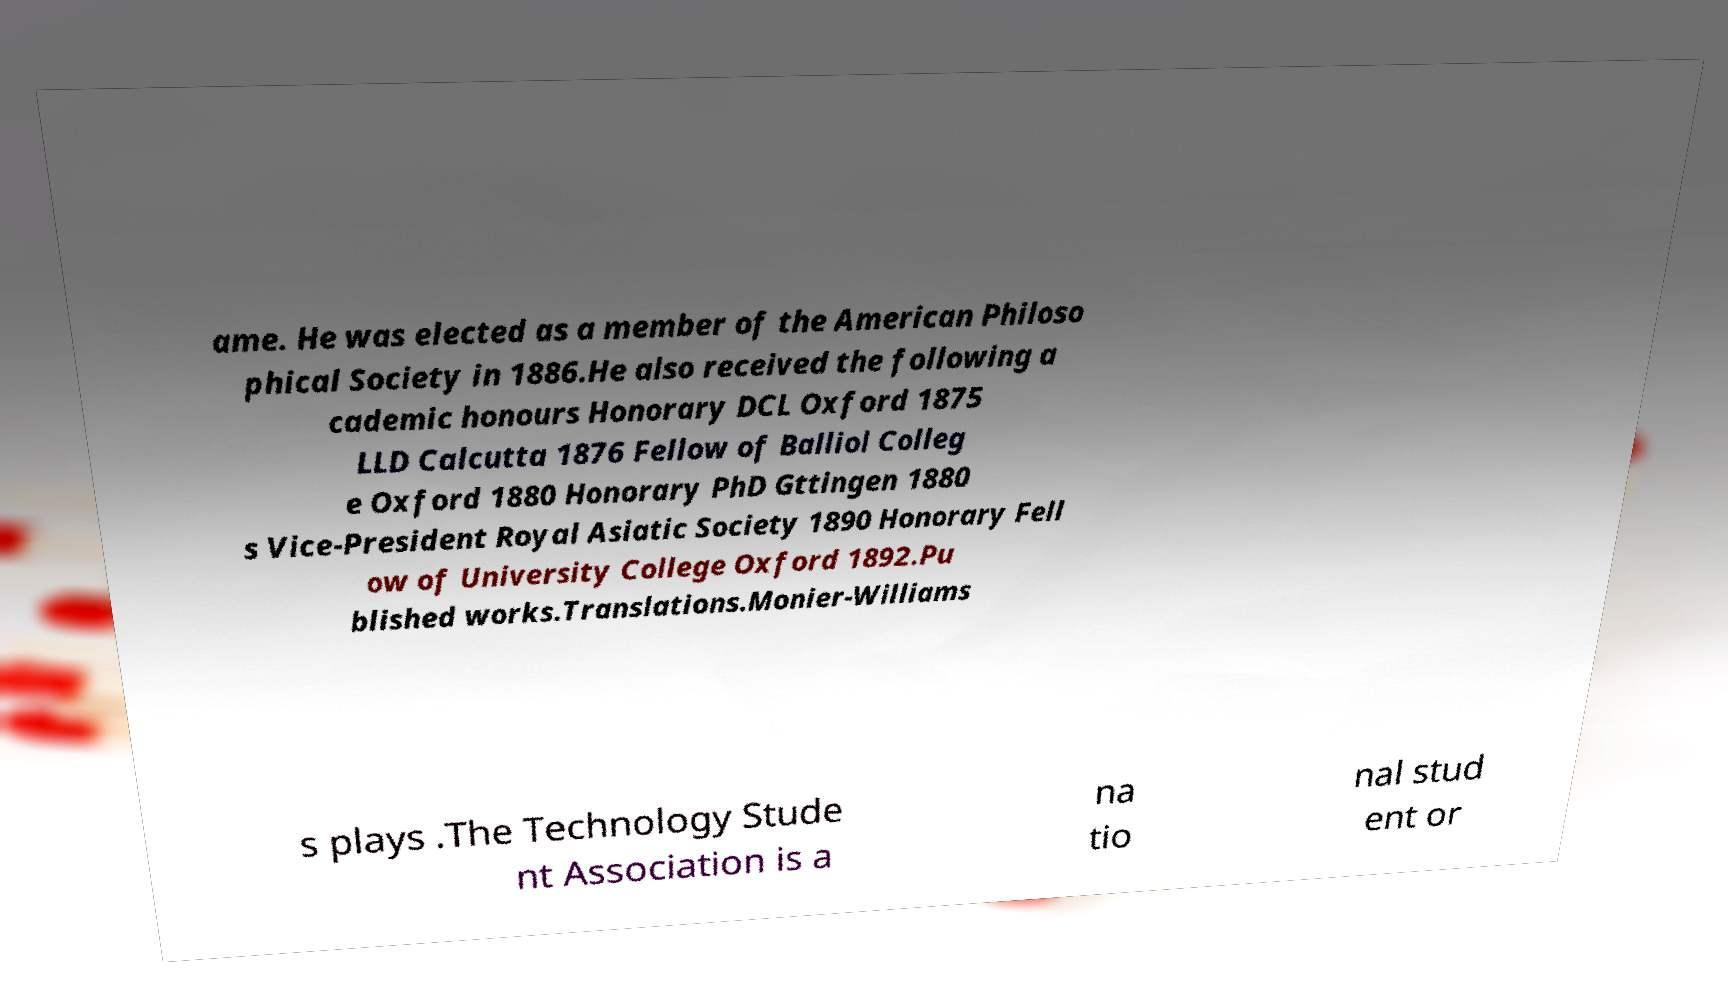Could you extract and type out the text from this image? ame. He was elected as a member of the American Philoso phical Society in 1886.He also received the following a cademic honours Honorary DCL Oxford 1875 LLD Calcutta 1876 Fellow of Balliol Colleg e Oxford 1880 Honorary PhD Gttingen 1880 s Vice-President Royal Asiatic Society 1890 Honorary Fell ow of University College Oxford 1892.Pu blished works.Translations.Monier-Williams s plays .The Technology Stude nt Association is a na tio nal stud ent or 